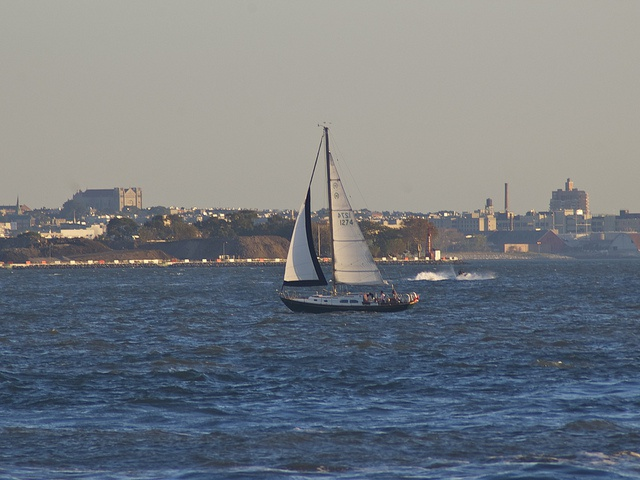Describe the objects in this image and their specific colors. I can see boat in darkgray, gray, and black tones, people in darkgray, gray, purple, and navy tones, people in darkgray, gray, black, and purple tones, people in darkgray, gray, and black tones, and people in darkgray, gray, khaki, and black tones in this image. 